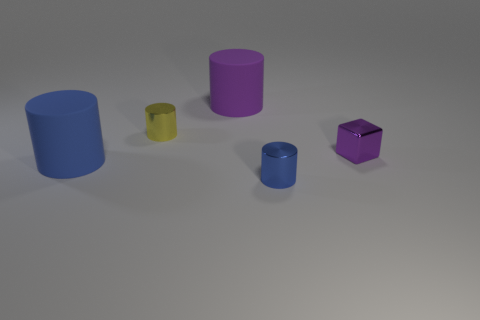What number of things are yellow metallic spheres or tiny cylinders?
Your answer should be very brief. 2. How many purple metal objects have the same size as the blue rubber object?
Offer a terse response. 0. What shape is the big matte object to the right of the big object in front of the tiny purple cube?
Your answer should be compact. Cylinder. Is the number of small blue cylinders less than the number of cylinders?
Your response must be concise. Yes. The cylinder that is in front of the large blue cylinder is what color?
Provide a short and direct response. Blue. There is a cylinder that is both behind the large blue matte cylinder and in front of the purple cylinder; what is its material?
Keep it short and to the point. Metal. What shape is the thing that is made of the same material as the purple cylinder?
Your response must be concise. Cylinder. How many purple things are right of the matte thing on the left side of the tiny yellow shiny object?
Offer a terse response. 2. How many metal things are both to the right of the small blue metal cylinder and to the left of the big purple rubber object?
Offer a terse response. 0. What number of other objects are the same material as the big blue thing?
Your answer should be very brief. 1. 